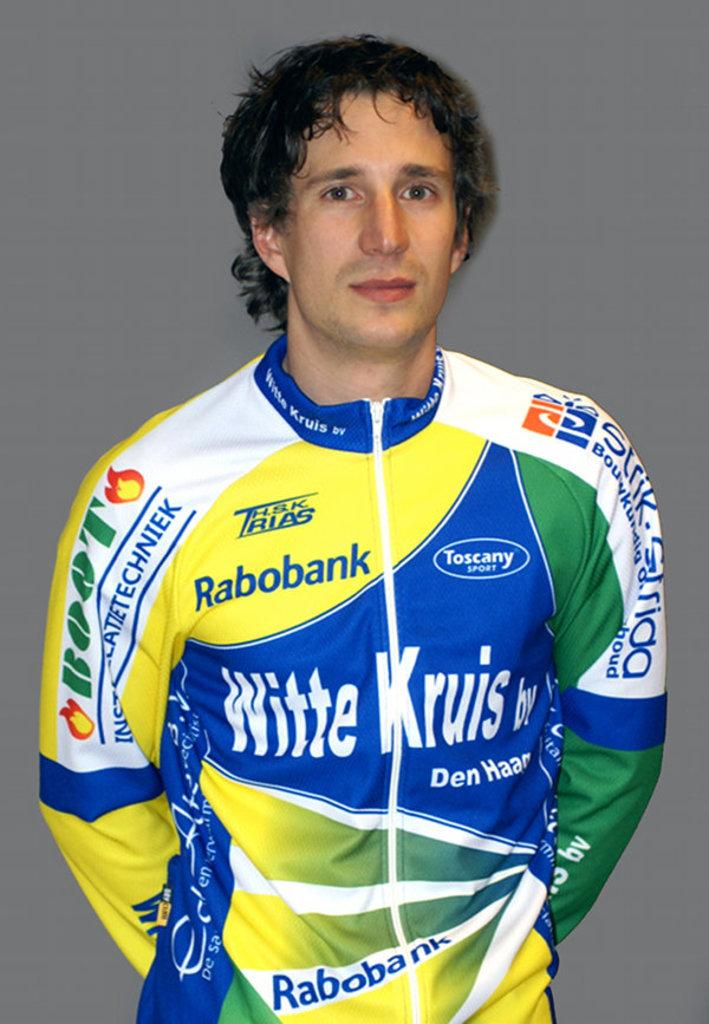<image>
Summarize the visual content of the image. A racer poses for a picture in his Witte Cruis, Rabobank,  Toscany Sport, and many more sponsored uniform. 